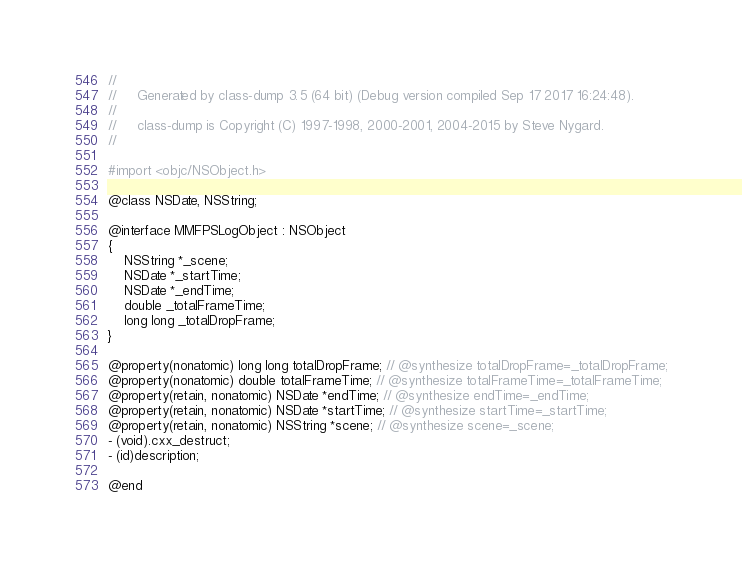<code> <loc_0><loc_0><loc_500><loc_500><_C_>//
//     Generated by class-dump 3.5 (64 bit) (Debug version compiled Sep 17 2017 16:24:48).
//
//     class-dump is Copyright (C) 1997-1998, 2000-2001, 2004-2015 by Steve Nygard.
//

#import <objc/NSObject.h>

@class NSDate, NSString;

@interface MMFPSLogObject : NSObject
{
    NSString *_scene;
    NSDate *_startTime;
    NSDate *_endTime;
    double _totalFrameTime;
    long long _totalDropFrame;
}

@property(nonatomic) long long totalDropFrame; // @synthesize totalDropFrame=_totalDropFrame;
@property(nonatomic) double totalFrameTime; // @synthesize totalFrameTime=_totalFrameTime;
@property(retain, nonatomic) NSDate *endTime; // @synthesize endTime=_endTime;
@property(retain, nonatomic) NSDate *startTime; // @synthesize startTime=_startTime;
@property(retain, nonatomic) NSString *scene; // @synthesize scene=_scene;
- (void).cxx_destruct;
- (id)description;

@end

</code> 